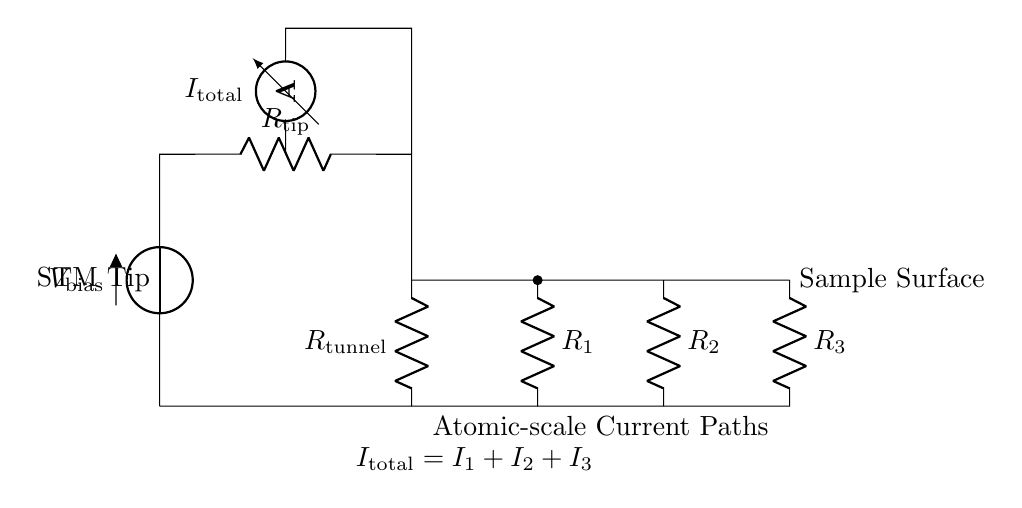What is the total current in this circuit? The total current is the sum of all current paths in the parallel configuration: I total = I 1 + I 2 + I 3. The circuit diagram indicates the presence of three resistors (R 1, R 2, R 3). By the principle of current division, the ammeter measures this total current, which is directly indicated in the diagram.
Answer: I total What are the names of the components connected in parallel? The components connected in parallel are R 1, R 2, and R 3. These resistors branch off from a common node (the connection with R tunnel) and share the same voltage across them. The circuit diagram visually separates these resistors from the others, clearly indicating their parallel configuration.
Answer: R 1, R 2, R 3 What does the ammeter represent in this circuit? The ammeter represents the total current flowing through the circuit. It is positioned to measure the current directly after the initial resistor (R tip) before dividing into parallel branches. The ammeter is annotated with the label I total, indicating its role in measuring the total circuit current.
Answer: Total current How are the resistances arranged in this circuit? The resistances in the circuit are arranged in parallel. This is evident from the configuration where R 1, R 2, and R 3 each connect to a common node and lead back to the same point, allowing the current to divide among them. The circuit diagram clearly shows these components branching from a single point, characteristic of a parallel arrangement.
Answer: Parallel What is the significance of the voltage across R tunnel? The voltage across R tunnel represents the bias voltage applied to the scanning tunneling microscope, which influences the tunneling current between the tip and the sample surface. The circuit diagram labels this potential as V bias, indicating that it is the voltage source driving the entire circuit and is crucial for the measurement of atomic-scale currents.
Answer: V bias How does the current divider principle apply in this circuit? The current divider principle applies by distributing the total current (I total) among the parallel resistors (R 1, R 2, R 3) based on their resistances. According to this principle, the current through each resistor is inversely proportional to its resistance, allowing for precise control and measurement of current paths at the atomic scale. The diagram illustrates this relationship through the equation presented.
Answer: Inversely proportional relationships What does "Atomic-scale Current Paths" refer to in this context? "Atomic-scale Current Paths" refers to the paths along which the tunneling current flows when the STM tip interacts with the sample surface. This phrase implies that the measurement involves extremely delicate and localized current pathways, relevant to atomic and subatomic levels of precision, as depicted in the circuit diagram with labels indicating their importance in the experiment.
Answer: Paths for tunneling current 